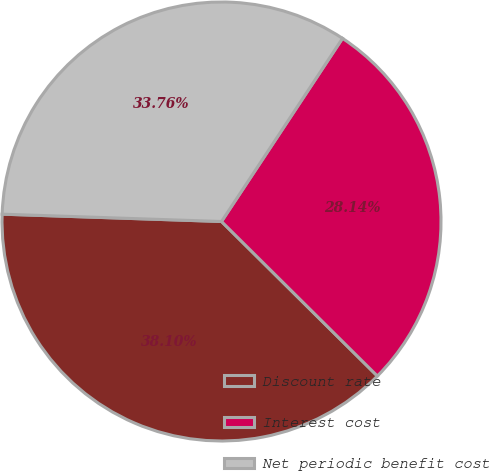Convert chart. <chart><loc_0><loc_0><loc_500><loc_500><pie_chart><fcel>Discount rate<fcel>Interest cost<fcel>Net periodic benefit cost<nl><fcel>38.1%<fcel>28.14%<fcel>33.76%<nl></chart> 